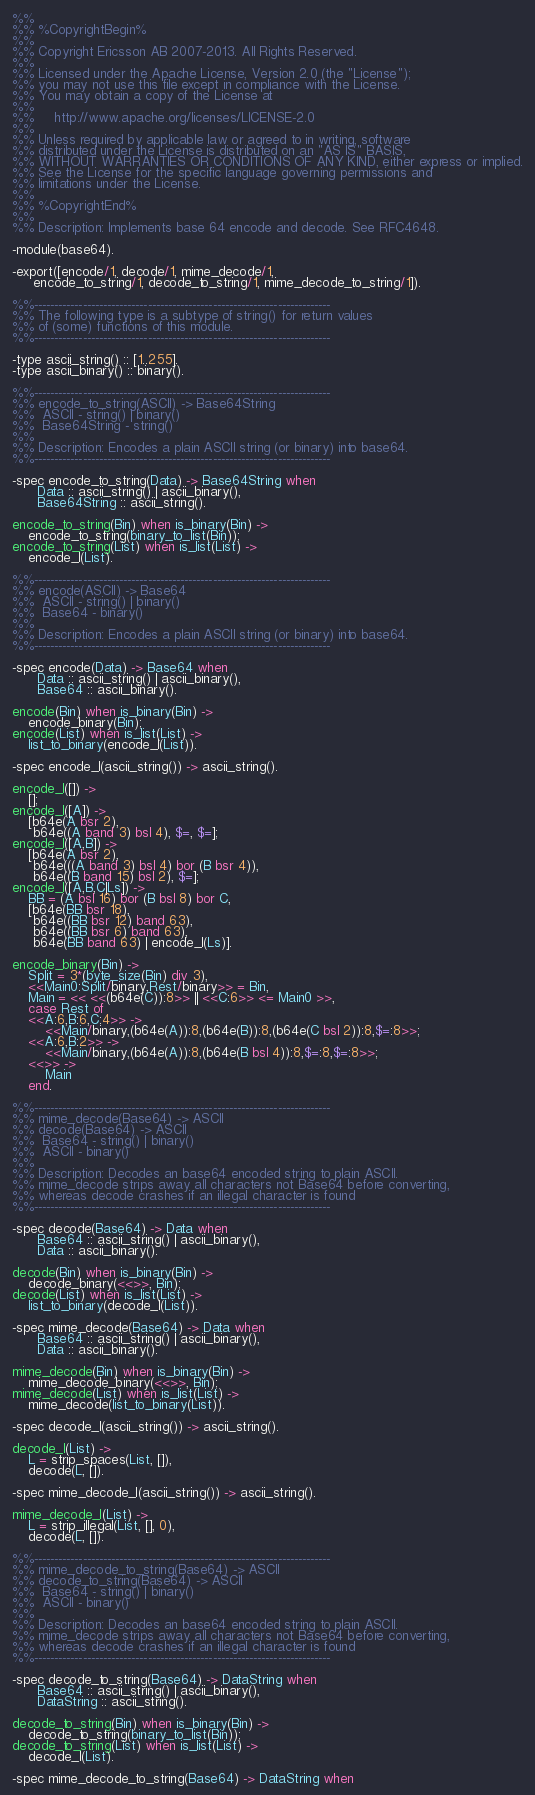<code> <loc_0><loc_0><loc_500><loc_500><_Erlang_>%%
%% %CopyrightBegin%
%% 
%% Copyright Ericsson AB 2007-2013. All Rights Reserved.
%% 
%% Licensed under the Apache License, Version 2.0 (the "License");
%% you may not use this file except in compliance with the License.
%% You may obtain a copy of the License at
%%
%%     http://www.apache.org/licenses/LICENSE-2.0
%%
%% Unless required by applicable law or agreed to in writing, software
%% distributed under the License is distributed on an "AS IS" BASIS,
%% WITHOUT WARRANTIES OR CONDITIONS OF ANY KIND, either express or implied.
%% See the License for the specific language governing permissions and
%% limitations under the License.
%% 
%% %CopyrightEnd%
%%
%% Description: Implements base 64 encode and decode. See RFC4648.

-module(base64).

-export([encode/1, decode/1, mime_decode/1,
	 encode_to_string/1, decode_to_string/1, mime_decode_to_string/1]).

%%-------------------------------------------------------------------------
%% The following type is a subtype of string() for return values
%% of (some) functions of this module.
%%-------------------------------------------------------------------------

-type ascii_string() :: [1..255].
-type ascii_binary() :: binary().

%%-------------------------------------------------------------------------
%% encode_to_string(ASCII) -> Base64String
%%	ASCII - string() | binary()
%%	Base64String - string()
%%                                   
%% Description: Encodes a plain ASCII string (or binary) into base64.
%%-------------------------------------------------------------------------

-spec encode_to_string(Data) -> Base64String when
      Data :: ascii_string() | ascii_binary(),
      Base64String :: ascii_string().

encode_to_string(Bin) when is_binary(Bin) ->
    encode_to_string(binary_to_list(Bin));
encode_to_string(List) when is_list(List) ->
    encode_l(List).

%%-------------------------------------------------------------------------
%% encode(ASCII) -> Base64
%%	ASCII - string() | binary()
%%	Base64 - binary()
%%                                   
%% Description: Encodes a plain ASCII string (or binary) into base64.
%%-------------------------------------------------------------------------

-spec encode(Data) -> Base64 when
      Data :: ascii_string() | ascii_binary(),
      Base64 :: ascii_binary().

encode(Bin) when is_binary(Bin) ->
    encode_binary(Bin);
encode(List) when is_list(List) ->
    list_to_binary(encode_l(List)).

-spec encode_l(ascii_string()) -> ascii_string().

encode_l([]) ->
    [];
encode_l([A]) ->
    [b64e(A bsr 2),
     b64e((A band 3) bsl 4), $=, $=];
encode_l([A,B]) ->
    [b64e(A bsr 2),
     b64e(((A band 3) bsl 4) bor (B bsr 4)), 
     b64e((B band 15) bsl 2), $=];
encode_l([A,B,C|Ls]) ->
    BB = (A bsl 16) bor (B bsl 8) bor C,
    [b64e(BB bsr 18),
     b64e((BB bsr 12) band 63), 
     b64e((BB bsr 6) band 63),
     b64e(BB band 63) | encode_l(Ls)].

encode_binary(Bin) ->
    Split = 3*(byte_size(Bin) div 3),
    <<Main0:Split/binary,Rest/binary>> = Bin,
    Main = << <<(b64e(C)):8>> || <<C:6>> <= Main0 >>,
    case Rest of
	<<A:6,B:6,C:4>> ->
	    <<Main/binary,(b64e(A)):8,(b64e(B)):8,(b64e(C bsl 2)):8,$=:8>>;
	<<A:6,B:2>> ->
	    <<Main/binary,(b64e(A)):8,(b64e(B bsl 4)):8,$=:8,$=:8>>;
	<<>> ->
	    Main
    end.

%%-------------------------------------------------------------------------
%% mime_decode(Base64) -> ASCII
%% decode(Base64) -> ASCII
%%	Base64 - string() | binary()
%%	ASCII - binary()
%%                                    
%% Description: Decodes an base64 encoded string to plain ASCII.
%% mime_decode strips away all characters not Base64 before converting,
%% whereas decode crashes if an illegal character is found
%%-------------------------------------------------------------------------

-spec decode(Base64) -> Data when
      Base64 :: ascii_string() | ascii_binary(),
      Data :: ascii_binary().

decode(Bin) when is_binary(Bin) ->
    decode_binary(<<>>, Bin);
decode(List) when is_list(List) ->
    list_to_binary(decode_l(List)).

-spec mime_decode(Base64) -> Data when
      Base64 :: ascii_string() | ascii_binary(),
      Data :: ascii_binary().

mime_decode(Bin) when is_binary(Bin) ->
    mime_decode_binary(<<>>, Bin);
mime_decode(List) when is_list(List) ->
    mime_decode(list_to_binary(List)).

-spec decode_l(ascii_string()) -> ascii_string().

decode_l(List) ->
    L = strip_spaces(List, []),
    decode(L, []).

-spec mime_decode_l(ascii_string()) -> ascii_string().

mime_decode_l(List) ->
    L = strip_illegal(List, [], 0),
    decode(L, []).

%%-------------------------------------------------------------------------
%% mime_decode_to_string(Base64) -> ASCII
%% decode_to_string(Base64) -> ASCII
%%	Base64 - string() | binary()
%%	ASCII - binary()
%%
%% Description: Decodes an base64 encoded string to plain ASCII.
%% mime_decode strips away all characters not Base64 before converting,
%% whereas decode crashes if an illegal character is found
%%-------------------------------------------------------------------------

-spec decode_to_string(Base64) -> DataString when
      Base64 :: ascii_string() | ascii_binary(),
      DataString :: ascii_string().

decode_to_string(Bin) when is_binary(Bin) ->
    decode_to_string(binary_to_list(Bin));
decode_to_string(List) when is_list(List) ->
    decode_l(List).

-spec mime_decode_to_string(Base64) -> DataString when</code> 